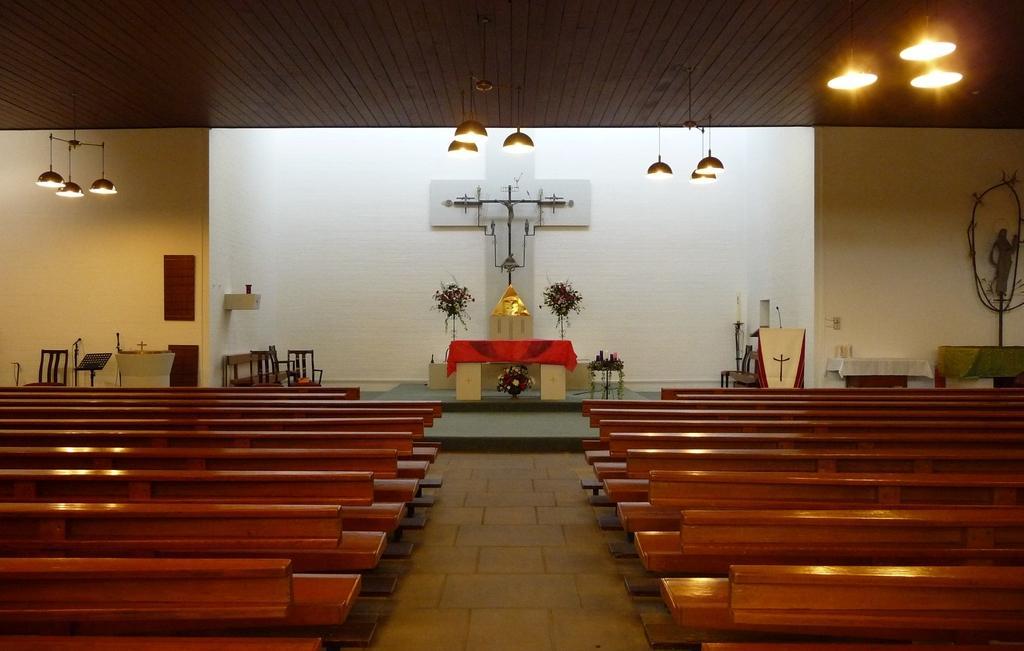In one or two sentences, can you explain what this image depicts? In this image we can see the inner view of a church and there are some benches and we can see a podium with a mic and there are some other objects. We can see a table and there are few flower vases and we can see the cross attached to the wall. There are some lights attached to the ceiling. 